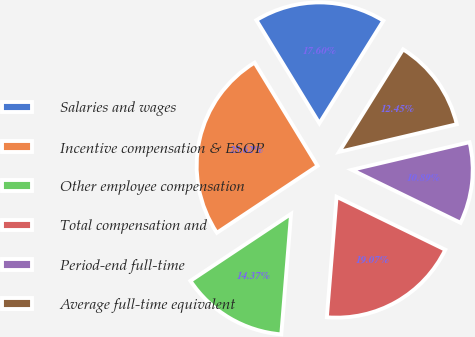<chart> <loc_0><loc_0><loc_500><loc_500><pie_chart><fcel>Salaries and wages<fcel>Incentive compensation & ESOP<fcel>Other employee compensation<fcel>Total compensation and<fcel>Period-end full-time<fcel>Average full-time equivalent<nl><fcel>17.6%<fcel>25.62%<fcel>14.37%<fcel>19.07%<fcel>10.89%<fcel>12.45%<nl></chart> 